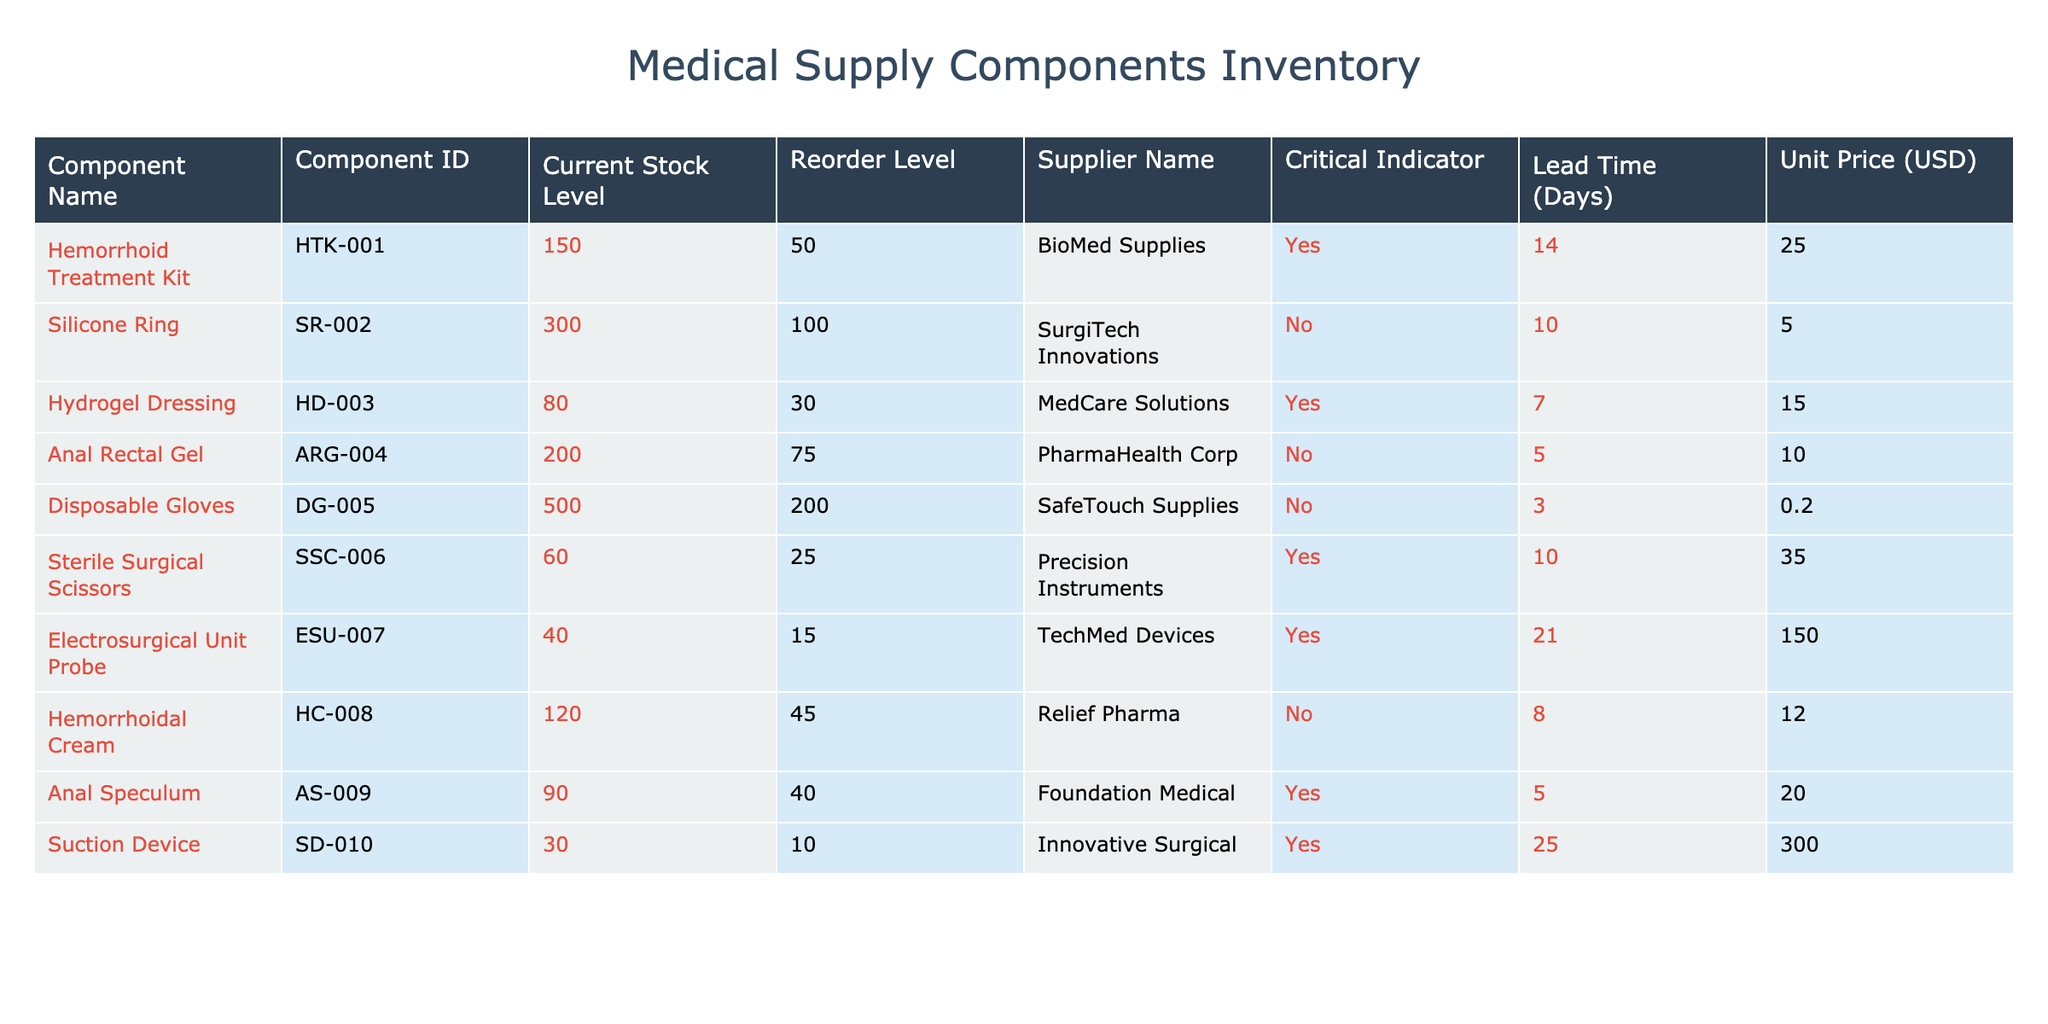What is the component ID for the Silicone Ring? The table lists the Silicone Ring under the Component Name column. Referring to the corresponding row in the Component ID column, the ID is SR-002.
Answer: SR-002 How many components have a reorder level set at 50 or less? Looking at the current stock level and reorder level, I need to filter components where the reorder level is at or below 50. The components meeting this criterion are Sterile Surgical Scissors (25), Electrosurgical Unit Probe (15), and Suction Device (10). This gives us a total of 3 components.
Answer: 3 Is the Hydrogel Dressing in the critical stock level category? Checking the Critical Indicator column for Hydrogel Dressing, it shows "Yes," which means it is in the critical stock level category.
Answer: Yes What is the total stock level of components from BioMed Supplies? To find the total stock level, I'll look for all components supplied by BioMed Supplies, which is the Hemorrhoid Treatment Kit (150) and no other components. Thus, the total is 150.
Answer: 150 What is the average lead time of components with a critical indicator of "Yes"? Filtering for components where the Critical Indicator is "Yes," I have the following lead times: 14 days for Hemorrhoid Treatment Kit, 7 days for Hydrogel Dressing, 10 days for Sterile Surgical Scissors, 21 days for Electrosurgical Unit Probe, and 25 days for Suction Device. The sum of these lead times is 77 days, and there are 5 components, so the average is 77/5 = 15.4 days.
Answer: 15.4 Are there any components with a current stock level below their reorder level? Reviewing the table, I see that both the Hydrogel Dressing (80 < 30) and the Electrosurgical Unit Probe (40 < 15) fall below their reorder levels. Therefore, the answer is true; there are components with this condition.
Answer: Yes Which component has the highest unit price? By examining the Unit Price column, I note that the Electrosurgical Unit Probe has the highest unit price at 150.00 USD compared to other components listed.
Answer: 150.00 USD What is the difference in stock levels between the Disposable Gloves and the Suction Device? The current stock level for Disposable Gloves is 500 while for the Suction Device it is 30. Therefore, the difference is calculated as 500 - 30 = 470.
Answer: 470 